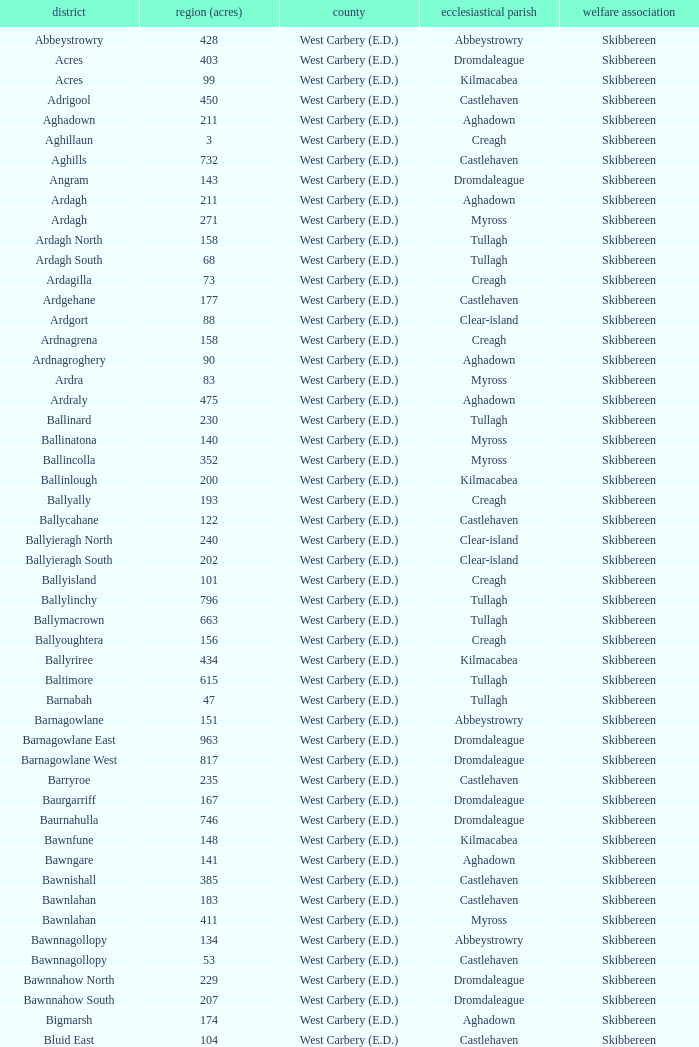What are the Poor Law Unions when the area (in acres) is 142? Skibbereen. 